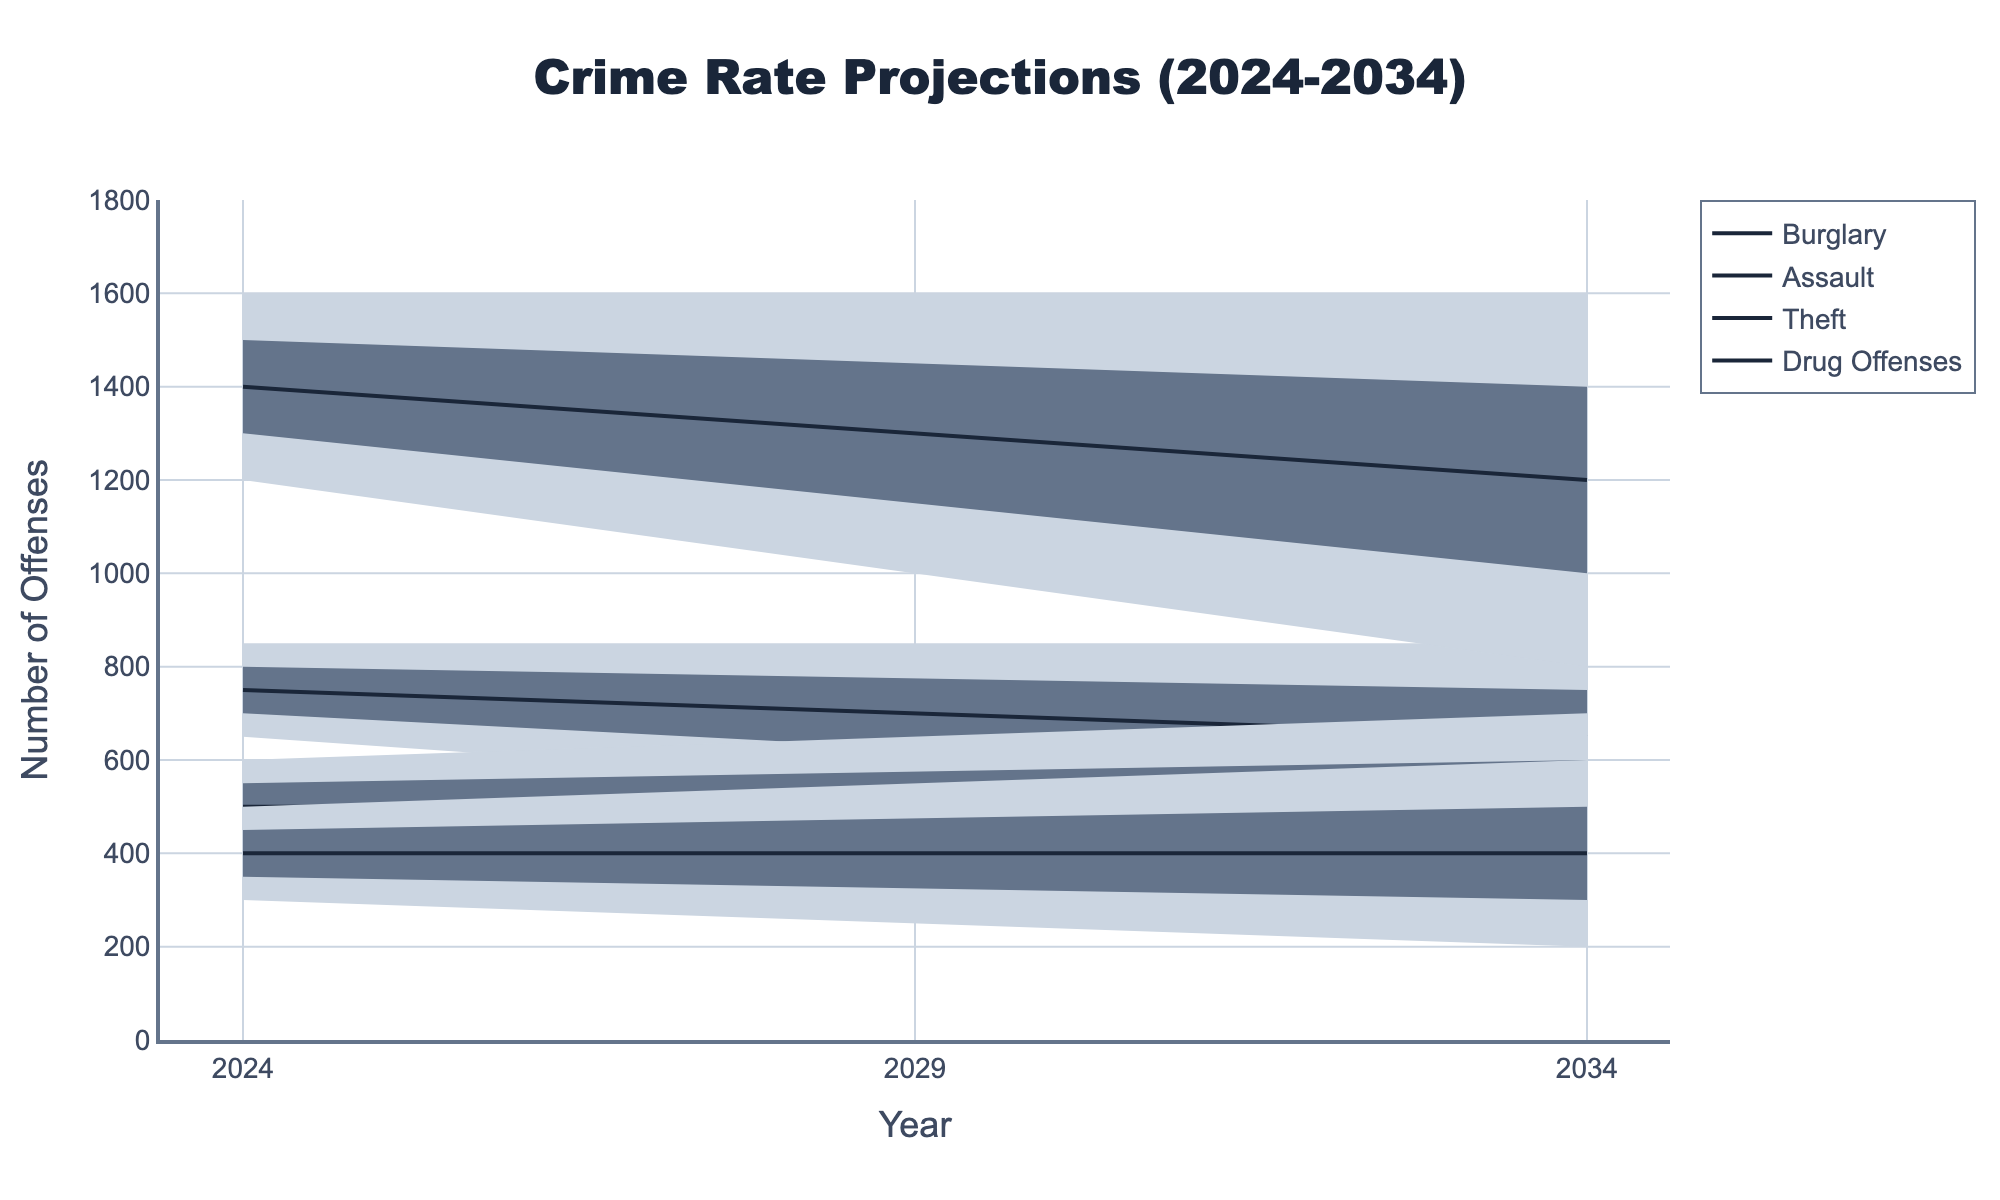What is the title of the figure? The title of the figure is displayed at the top and reads "Crime Rate Projections (2024-2034)".
Answer: Crime Rate Projections (2024-2034) What is the projected mid-value for Theft offenses in 2029? Find the mid-values for Theft offenses in 2029 from the figure's legend or labels. The mid-value for Theft in 2029 is 1300.
Answer: 1300 How does the mid-value projection for Burglary in 2029 compare to 2024? Obtain both mid-values for Burglary in 2024 and 2029, then compare. The mid-value for Burglary in 2024 is 750, and for 2029 it is 700, so it decreases by 50.
Answer: It decreases by 50 Which offense category shows the highest uncertainty range (difference between high and low values) in 2034? Calculate the difference between high and low values for each offense in 2034 and compare. Theft has the highest uncertainty range with a difference of (1600 - 800 = 800).
Answer: Theft What is the trend of Drug Offenses from 2024 to 2034 in terms of mid-values? Observe the mid-values for Drug Offenses at different years and note their general movement. In this case, the mid-values are 400 in 2024, 400 in 2029, and 400 in 2034, indicating no change.
Answer: No change How much does the mid-high value of Assault decrease from 2024 to 2034? Check the mid-high values for Assault in 2024 and 2034 and subtract the latter from the former. The mid-high value for Assault decreases from 550 in 2024 to 600 in 2034, resulting in a change of (600 - 550 = 50).
Answer: Decreases by 50 How does the uncertainty range for Assault in 2024 (high-low) compare to that in 2029? Calculate the uncertainty ranges for Assault in both years, then compare the values. For 2024, the range is (600-400 = 200), and for 2029, it's (650-350 = 300). Thus, the range increases by 100.
Answer: Increases by 100 What trend can be observed about the mid-values of Burglary from 2024 to 2034? Observe the mid-values for Burglary over the specified years: 750 in 2024, 700 in 2029, and 650 in 2034, which shows a downward trend.
Answer: Downward trend In which year does Theft have the lowest mid-value projection? Check the mid-value projections for Theft in all given years and identify the lowest. The mid-values are 1400 in 2024, 1300 in 2029, and 1200 in 2034. The lowest mid-value is in 2034.
Answer: 2034 What is the difference between the high projections for Burglary and Drug Offenses in 2034? Subtract the high projection for Drug Offenses from the high projection for Burglary in 2034. The high values are 850 for Burglary and 600 for Drug Offenses, resulting in a difference of (850 - 600 = 250).
Answer: 250 